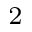Convert formula to latex. <formula><loc_0><loc_0><loc_500><loc_500>_ { 2 }</formula> 